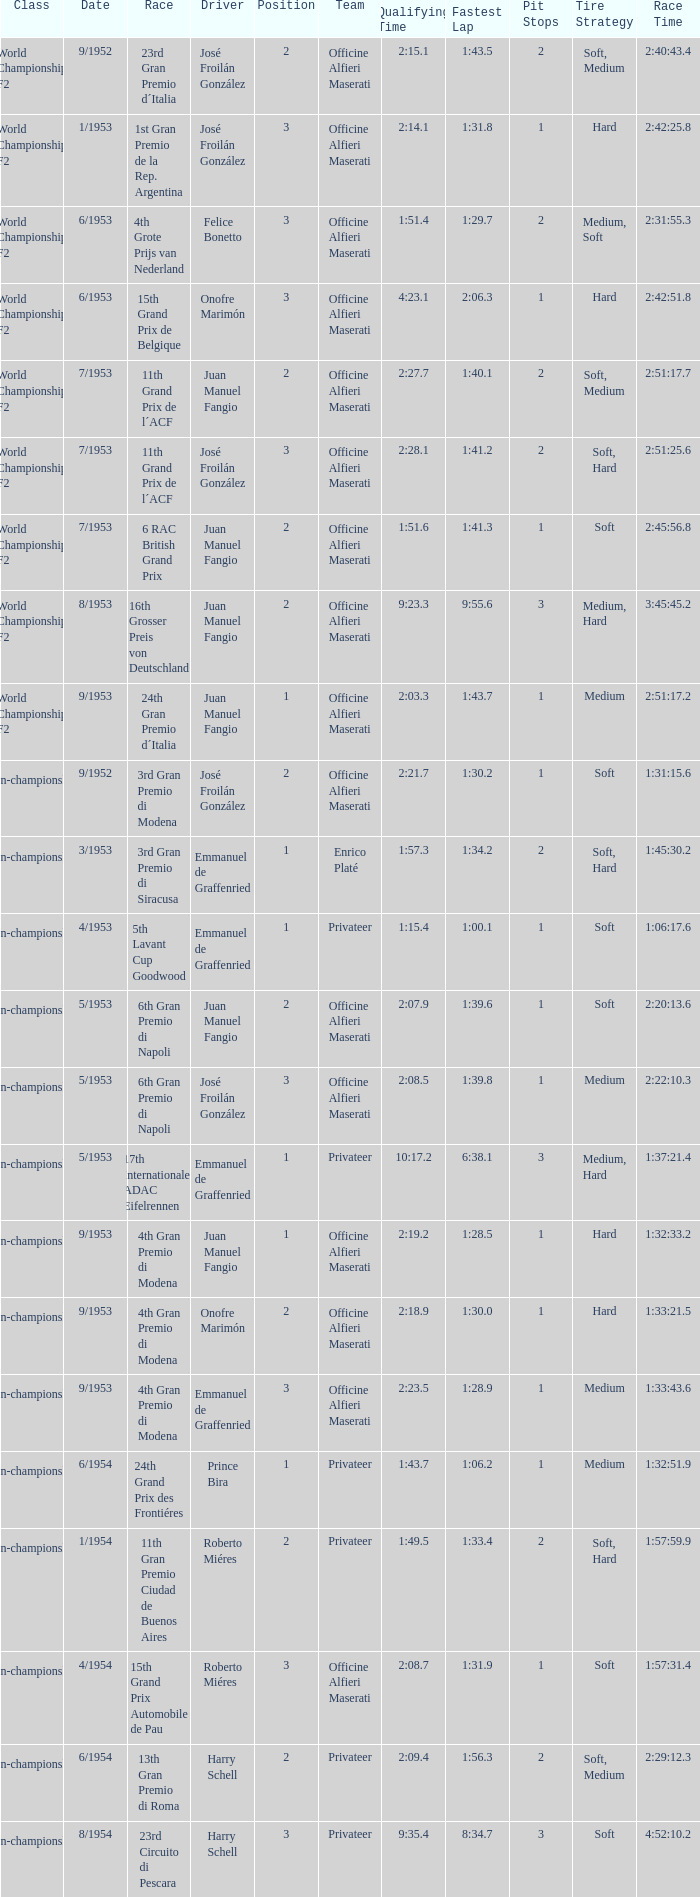What team has a drive name emmanuel de graffenried and a position larger than 1 as well as the date of 9/1953? Officine Alfieri Maserati. 